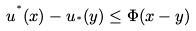Convert formula to latex. <formula><loc_0><loc_0><loc_500><loc_500>u ^ { ^ { * } } ( x ) - u _ { ^ { * } } ( y ) \leq \Phi ( x - y )</formula> 